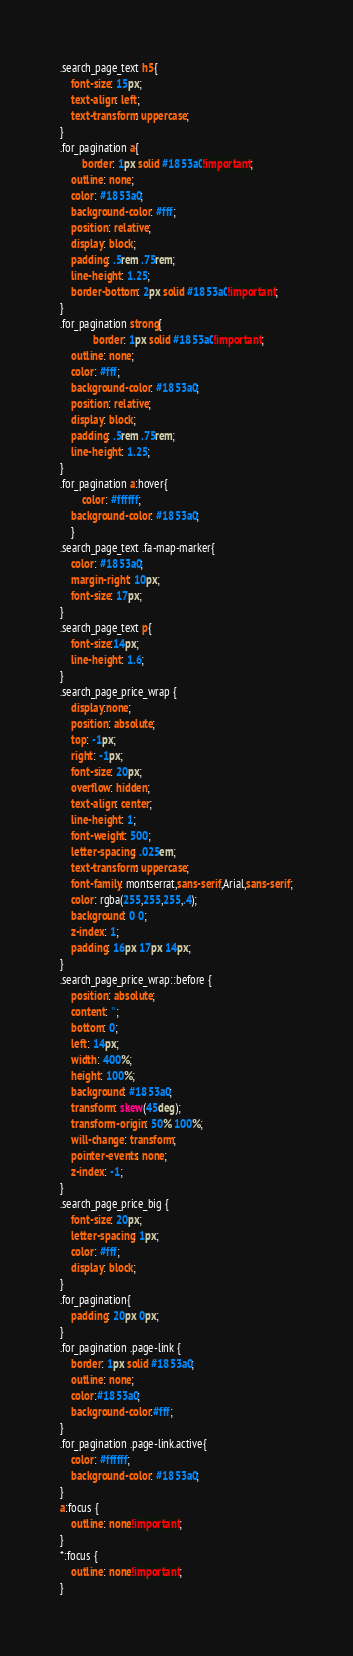Convert code to text. <code><loc_0><loc_0><loc_500><loc_500><_CSS_>.search_page_text h5{
	font-size: 15px;
    text-align: left;
    text-transform: uppercase;
}
.for_pagination a{
	    border: 1px solid #1853a0!important;
    outline: none;
    color: #1853a0;
    background-color: #fff;
    position: relative;
    display: block;
    padding: .5rem .75rem;
    line-height: 1.25;
    border-bottom: 2px solid #1853a0!important;
}
.for_pagination strong{
    	    border: 1px solid #1853a0!important;
    outline: none;
    color: #fff;
    background-color: #1853a0;
    position: relative;
    display: block;
    padding: .5rem .75rem;
    line-height: 1.25;
}
.for_pagination a:hover{
	    color: #ffffff;
    background-color: #1853a0;
    }
.search_page_text .fa-map-marker{
    color: #1853a0;
    margin-right: 10px;
	font-size: 17px;
}
.search_page_text p{
	font-size:14px;
	line-height: 1.6;
}
.search_page_price_wrap {
	display:none;
	position: absolute;
	top: -1px;
    right: -1px;
    font-size: 20px;
    overflow: hidden;
    text-align: center;
    line-height: 1;
    font-weight: 500;
    letter-spacing: .025em;
    text-transform: uppercase;
    font-family: montserrat,sans-serif,Arial,sans-serif;
    color: rgba(255,255,255,.4);
    background: 0 0;
    z-index: 1;
	padding: 16px 17px 14px;
}
.search_page_price_wrap::before {
	position: absolute;
    content: '';
    bottom: 0;
    left: 14px;
    width: 400%;
    height: 100%;
    background: #1853a0;
    transform: skew(45deg);
    transform-origin: 50% 100%;
    will-change: transform;
    pointer-events: none;
    z-index: -1;
}
.search_page_price_big {
	font-size: 20px;
    letter-spacing: 1px;
    color: #fff;
    display: block;
}
.for_pagination{
	padding: 20px 0px;
}
.for_pagination .page-link {
    border: 1px solid #1853a0;
	outline: none;
	color:#1853a0;
	background-color:#fff;
}
.for_pagination .page-link.active{
	color: #ffffff;
    background-color: #1853a0;
}
a:focus {
	outline: none!important;
}
*:focus {
	outline: none!important;
}</code> 